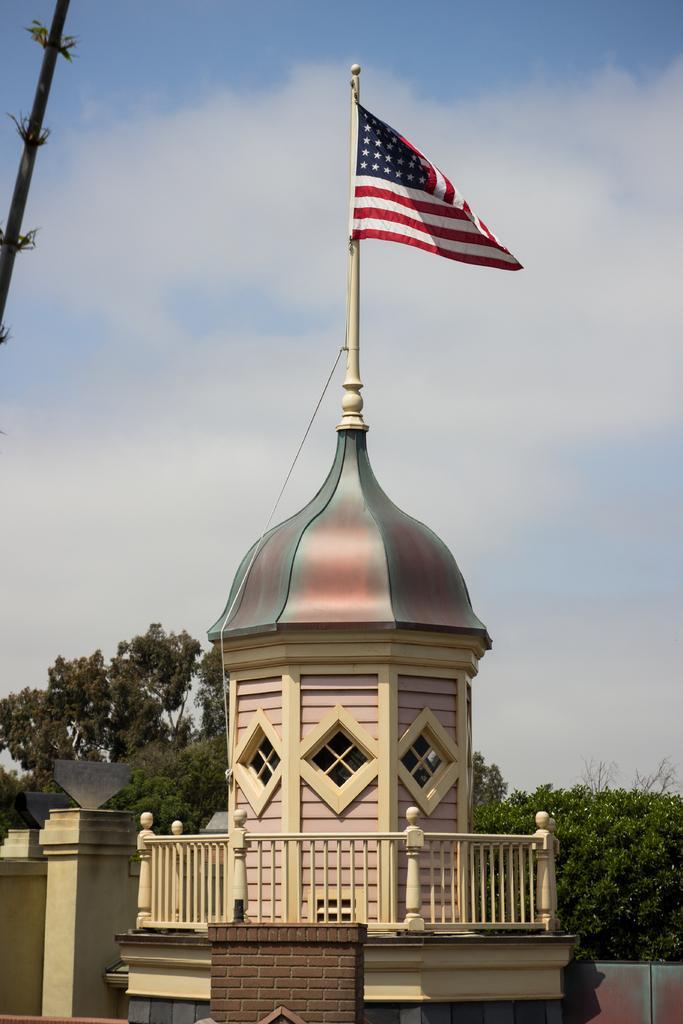How would you summarize this image in a sentence or two? In the center of the image we can see flag to the building. In the background we can see trees, sky and clouds. 